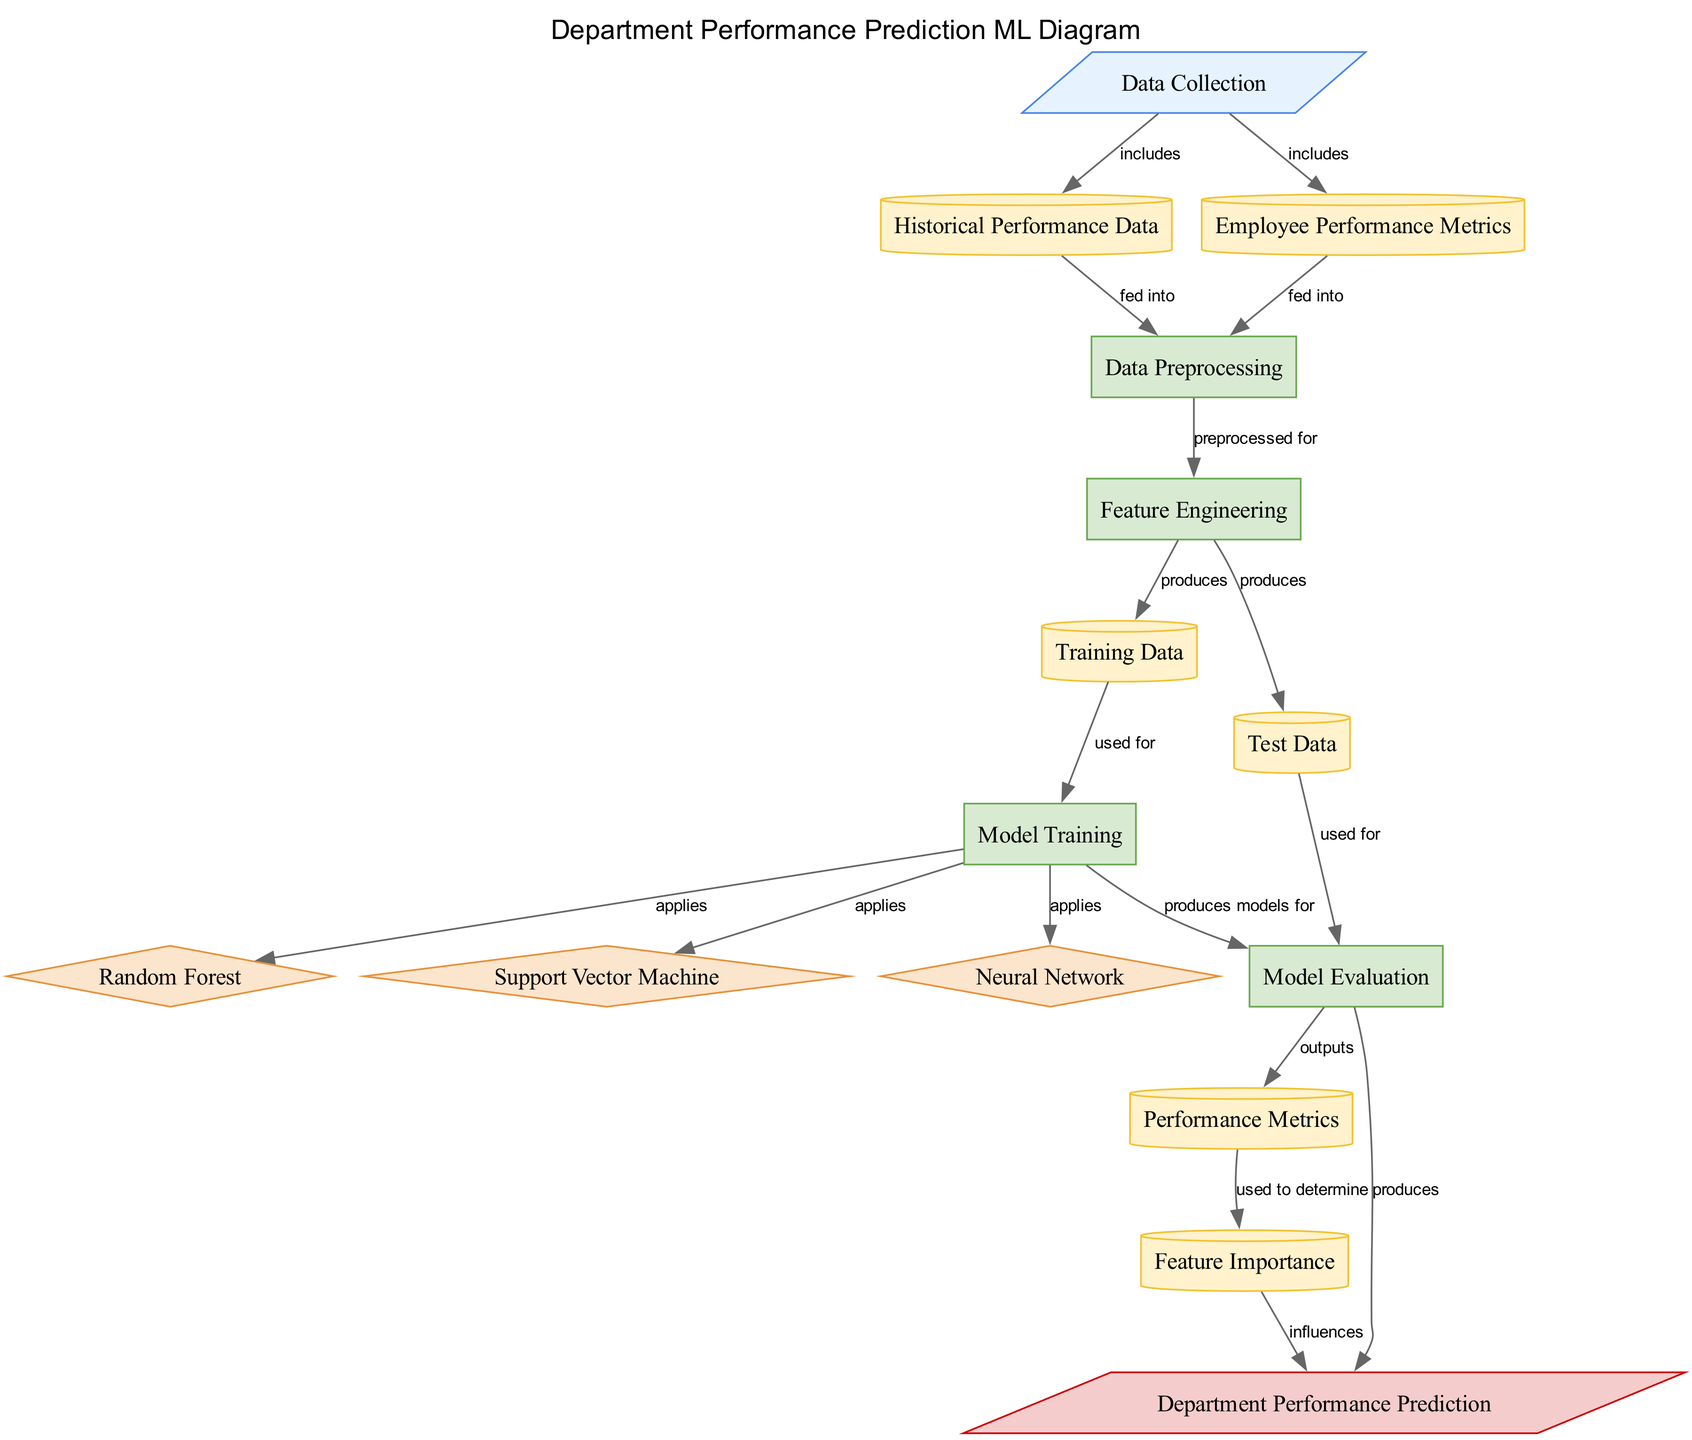What is the output of this diagram? The final output node in the diagram is "Department Performance Prediction," showing that the process results in predicting the department’s performance for the next quarter.
Answer: Department Performance Prediction How many algorithms are used in the model training process? In the diagram, there are three algorithms listed: Random Forest, Support Vector Machine, and Neural Network, indicating a total of three algorithms are used.
Answer: Three What data is produced after Feature Engineering? The "Feature Engineering" process results in two outputs: "Training Data" and "Test Data," which are utilized for model training and model evaluation respectively.
Answer: Training Data, Test Data What does "Model Evaluation" output? The "Model Evaluation" process produces "Performance Metrics," indicating that the evaluation phase assesses the model’s performance based on various metrics.
Answer: Performance Metrics Which process precedes "Model Training"? According to the diagram, "Training Data" is used for "Model Training," indicating that preprocessing and feature engineering steps must precede this training process.
Answer: Data Preprocessing What influences "Department Performance Prediction"? "Department Performance Prediction" is influenced by both "Performance Metrics" and "Feature Importance," suggesting that these factors are crucial in making future predictions.
Answer: Performance Metrics, Feature Importance What type of data enters the "Data Preprocessing" process? "Data Preprocessing" receives "Historical Performance Data" and "Employee Performance Metrics" as inputs, which need to be preprocessed before feature engineering and subsequent steps.
Answer: Historical Performance Data, Employee Performance Metrics How many nodes represent data in the diagram? The diagram includes four distinct data nodes: "Historical Performance Data," "Employee Performance Metrics," "Training Data," and "Test Data." This results in a total of four data nodes.
Answer: Four 